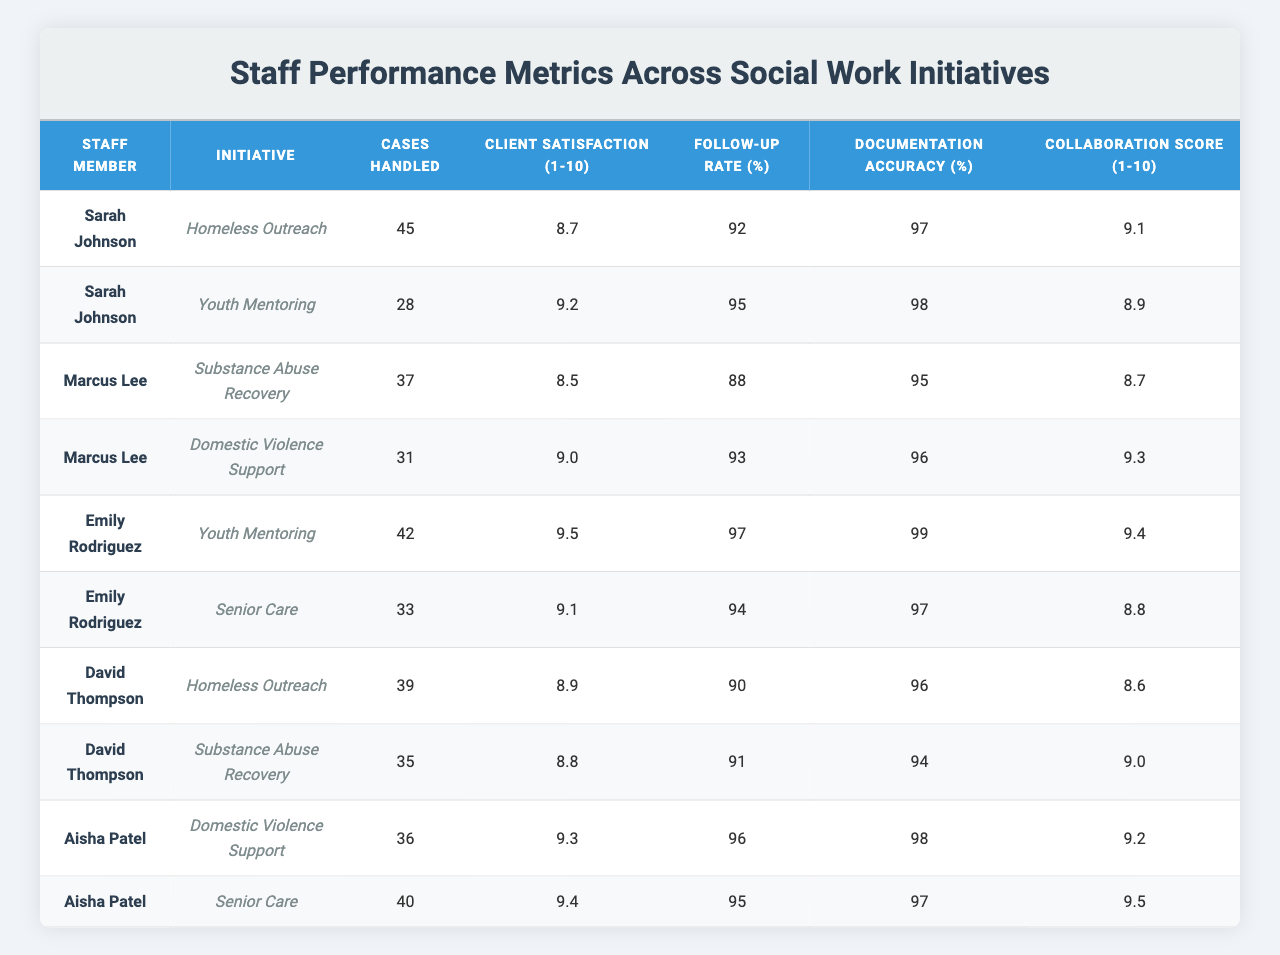What is the highest Client Satisfaction score among all staff members? The highest Client Satisfaction score is identified by scanning the table for the highest value in the "Client Satisfaction (1-10)" column. Emily Rodriguez has a score of 9.5, which is the highest when compared to other staff members.
Answer: 9.5 Which staff member handled the most cases in the Homeless Outreach initiative? To find the staff member who handled the most cases in the Homeless Outreach initiative, we look at the "Cases Handled" column for the Homeless Outreach row. Sarah Johnson handled 45 cases, which is more than David Thompson, who handled 39 cases.
Answer: Sarah Johnson Calculate the average Documentation Accuracy percentage across all initiatives for Marcus Lee. Marcus Lee has the Documentation Accuracy percentages of 95% for Substance Abuse Recovery and 96% for Domestic Violence Support. To calculate the average, we add these values: 95 + 96 = 191, and then divide by 2. The average is 191/2 = 95.5%.
Answer: 95.5 Did any staff member achieve a Follow-up Rate of over 95% in the Youth Mentoring initiative? To answer this, we check the Follow-up Rate for Youth Mentoring. Emily Rodriguez has a Follow-up Rate of 97%, which is over 95%. Thus, the answer to the question is yes.
Answer: Yes Which initiative has the highest Collaboration Score among all staff members? We look through the "Collaboration Score (1-10)" column for all initiatives and find the highest score, which is 9.5 from Aisha Patel in the Senior Care initiative.
Answer: Senior Care What is the total number of cases handled by David Thompson across all initiatives? For David Thompson, we sum the cases handled in both initiatives: 39 cases in Homeless Outreach and 35 cases in Substance Abuse Recovery. The total is 39 + 35 = 74.
Answer: 74 Is Aisha Patel the only staff member to achieve a Collaboration Score of 9 or higher in both of her initiatives? Aisha Patel has scores of 9.2 in Domestic Violence Support and 9.5 in Senior Care. We compare her scores to others: Sarah Johnson has 9.1 and 8.9, Emily Rodriguez has scores of 9.4 and 8.8, and Marcus Lee has scores of 8.7 and 9.3. Since Aisha is the only one with both scores above 9, the answer is yes.
Answer: Yes What is the difference in Client Satisfaction scores between Marcus Lee and Emily Rodriguez? Marcus Lee's Client Satisfaction score is 8.5 for Substance Abuse Recovery and 9.0 for Domestic Violence Support. Emily Rodriguez's scores are 9.5 and 9.1. The maximum score for Emily is 9.5. To find the difference, we subtract Marcus's maximum score (9.0) from Emily's (9.5): 9.5 - 9.0 = 0.5.
Answer: 0.5 Identify the staff member with the lowest Follow-up Rate in their initiatives. Checking the Follow-up Rates, Marcus Lee has 88% for Substance Abuse Recovery and 93% for Domestic Violence Support, while others have higher rates. None have lower than 88%, meaning Marcus holds the lowest.
Answer: Marcus Lee Which staff member has the highest average cases handled across all their initiatives? Calculating the average for each staff member: Sarah Johnson (45 + 28)/2 = 36.5, Marcus Lee (37 + 31)/2 = 34, Emily Rodriguez (42 + 33)/2 = 37.5, David Thompson (39 + 35)/2 = 37, Aisha Patel (36 + 40)/2 = 38. The highest average is for Aisha Patel with 38 to be the answer.
Answer: Aisha Patel 